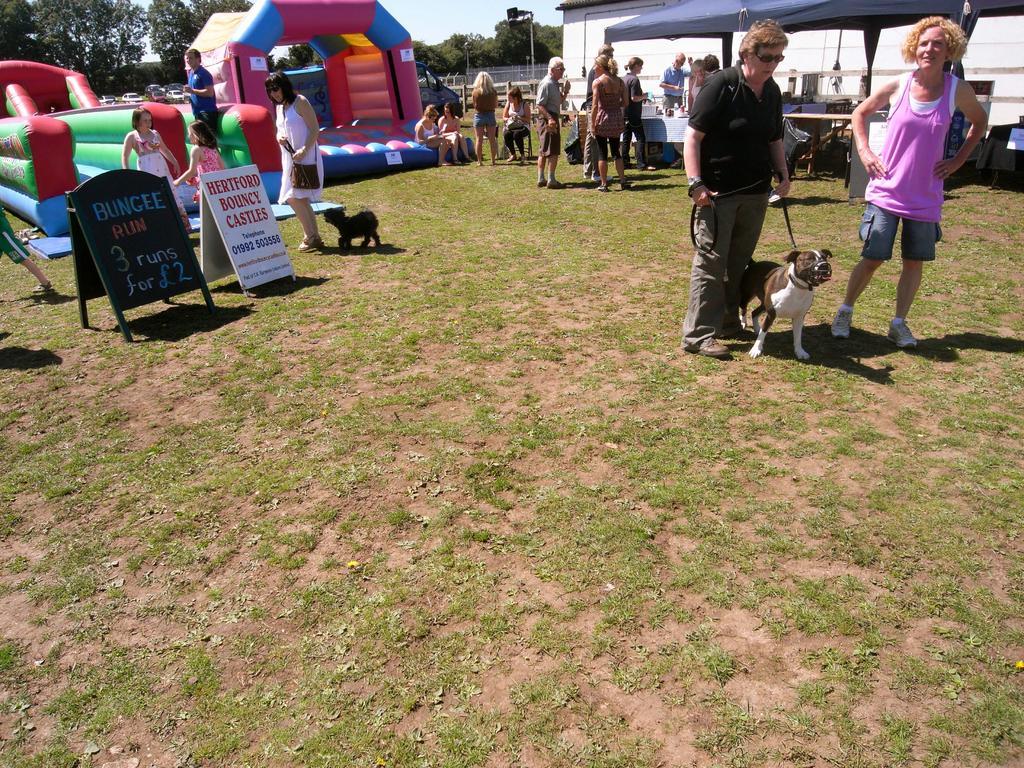Please provide a concise description of this image. Hindi picture there is a dog show in the garden. In the front we can see two old women holding the dog rope, standing and talking. Behind there is a group of old man and woman standing and discussing something. On the left side there is a playing ground for the dogs. In the front bottom side there are two banner boards is placed on the ground. 